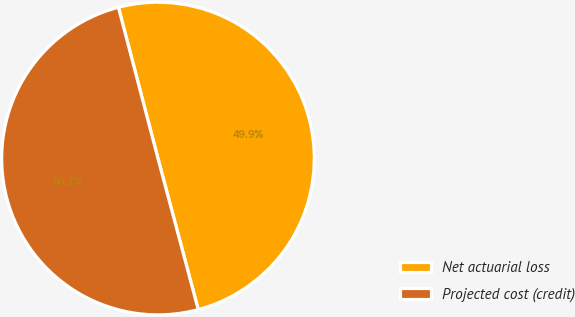Convert chart to OTSL. <chart><loc_0><loc_0><loc_500><loc_500><pie_chart><fcel>Net actuarial loss<fcel>Projected cost (credit)<nl><fcel>49.93%<fcel>50.07%<nl></chart> 